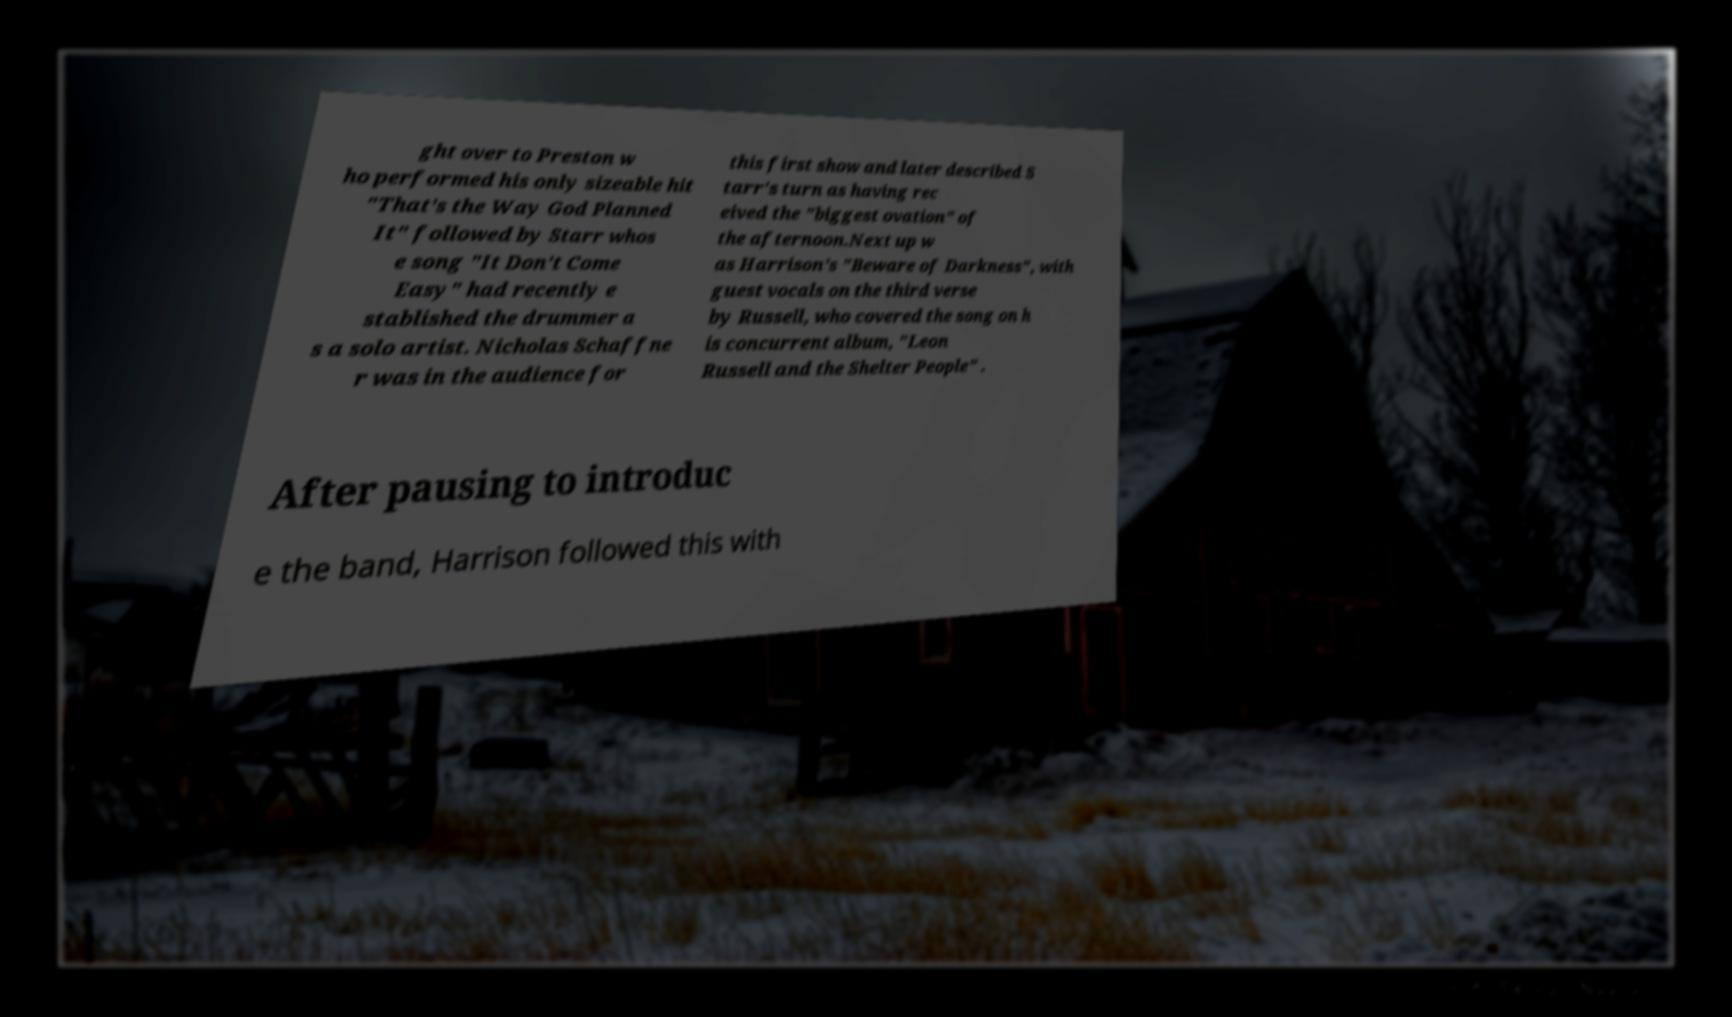Can you accurately transcribe the text from the provided image for me? ght over to Preston w ho performed his only sizeable hit "That's the Way God Planned It" followed by Starr whos e song "It Don't Come Easy" had recently e stablished the drummer a s a solo artist. Nicholas Schaffne r was in the audience for this first show and later described S tarr's turn as having rec eived the "biggest ovation" of the afternoon.Next up w as Harrison's "Beware of Darkness", with guest vocals on the third verse by Russell, who covered the song on h is concurrent album, "Leon Russell and the Shelter People" . After pausing to introduc e the band, Harrison followed this with 